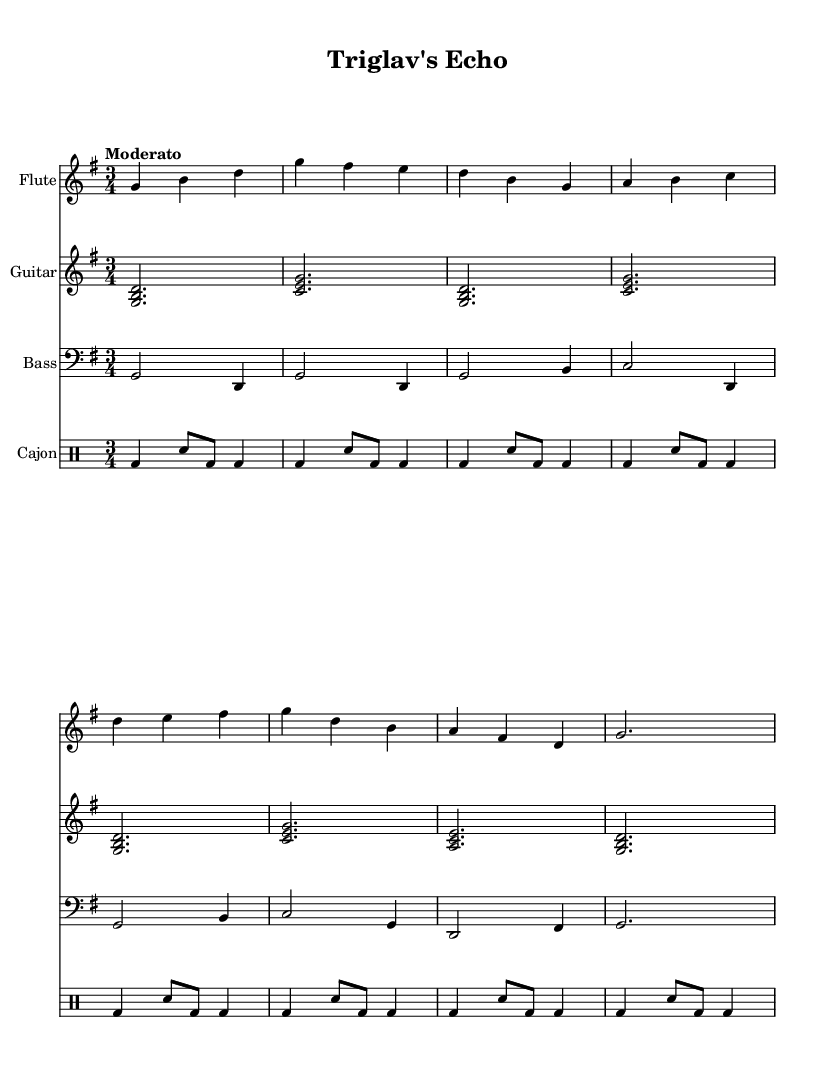What is the key signature of this music? The key signature shows one sharp (F#), indicating that the piece is in G major.
Answer: G major What is the time signature of this piece? The time signature indicated is 3/4, meaning there are three beats in a measure, and the quarter note gets one beat.
Answer: 3/4 What is the tempo marking for this composition? The score indicates a tempo marking of "Moderato," suggesting a moderate pace of play.
Answer: Moderato How many measures are played by the flute? By counting the measures between the bar lines in the flute part, there are 8 measures present.
Answer: 8 What is the instrument used for percussion in the score? The score defines the percussion instrument as a Cajon, which is a box-shaped percussion instrument played by slapping the front or rear faces.
Answer: Cajon Which instruments are featured in this composition? The score includes Flute, Guitar, Bass, and Cajon as the instruments being performed in this piece.
Answer: Flute, Guitar, Bass, Cajon What is the pattern of the lyrics in the song? The lyrics are structured to reflect the theme of the song, primarily revolving around the pride and majestic imagery associated with Triglav mountain and its surroundings, indicating a traditional Slovenian context.
Answer: Traditional Slovenian context 